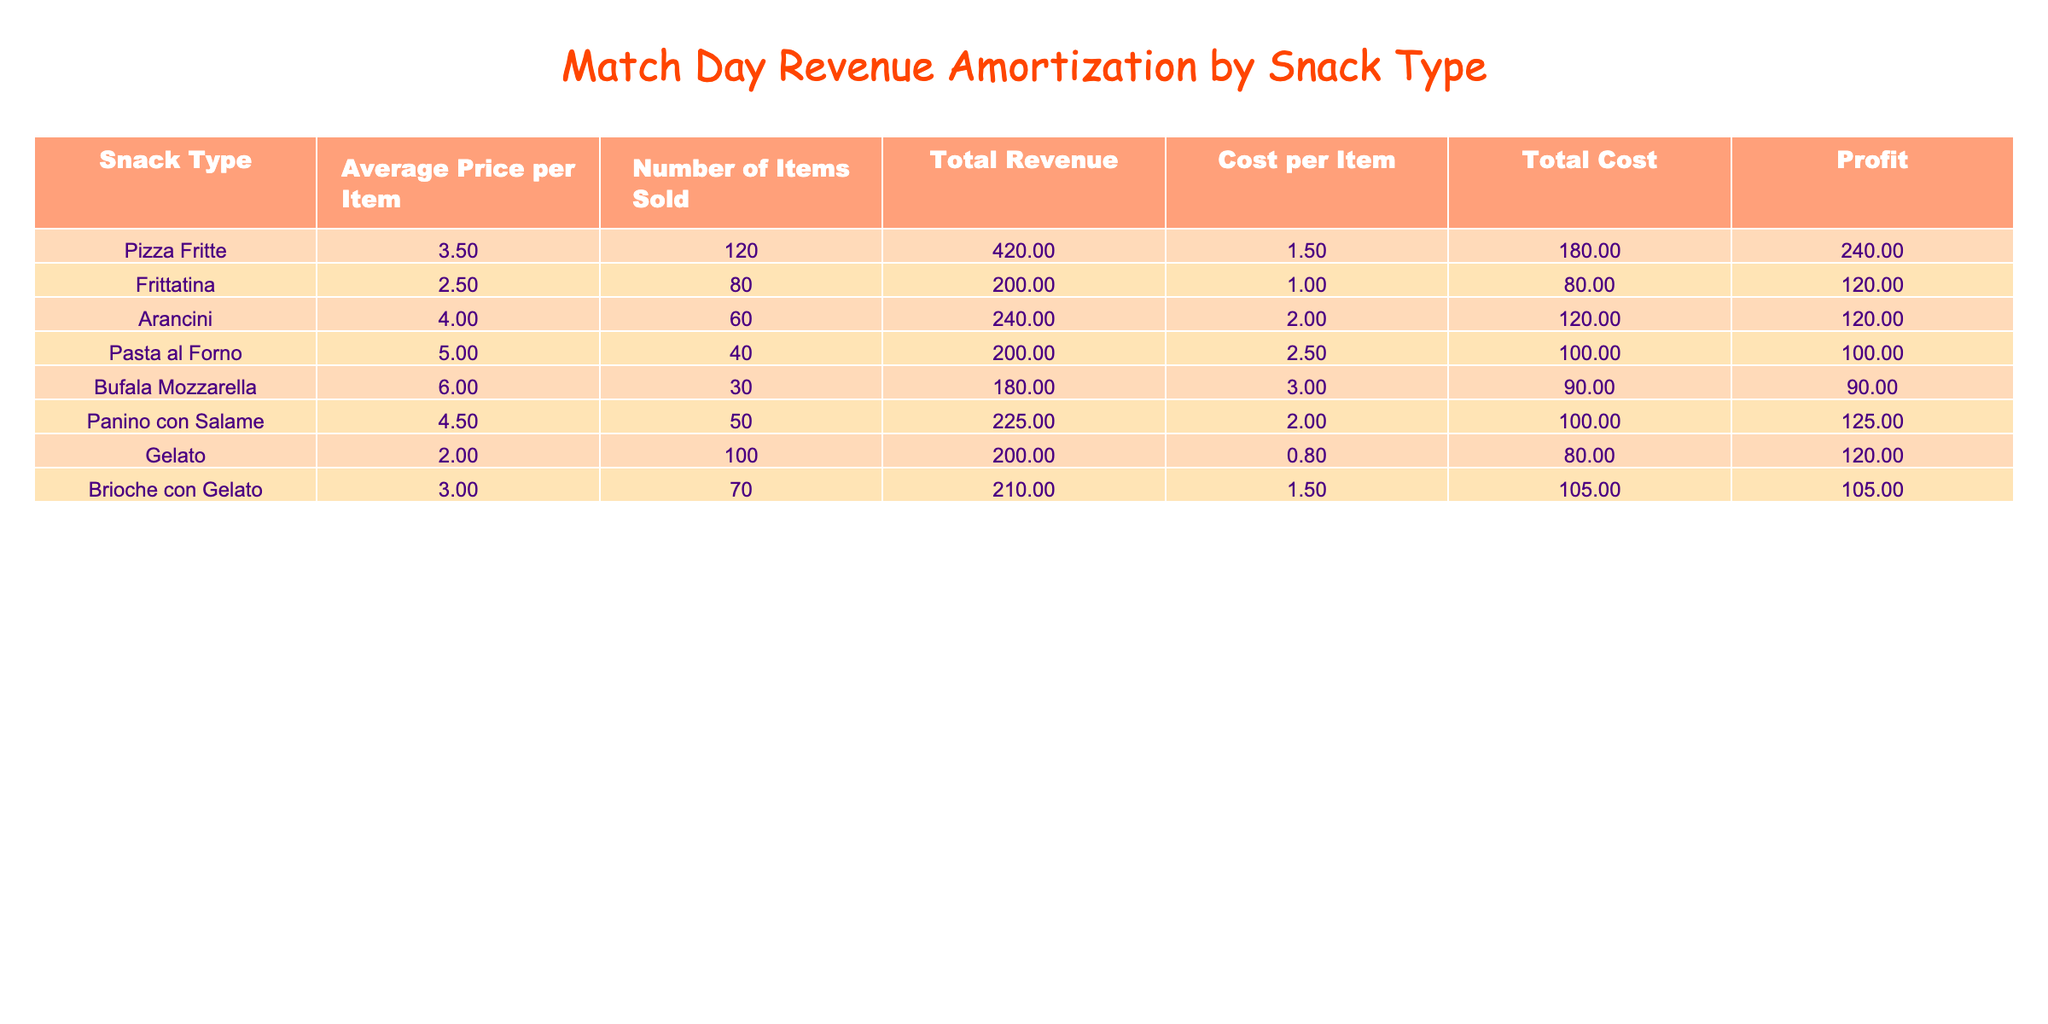What is the total revenue generated from Pizza Fritte? According to the table, the total revenue for Pizza Fritte is listed directly in the Total Revenue column. The value is 420.00.
Answer: 420.00 How many items of Arancini were sold? Looking at the Number of Items Sold column, the entry for Arancini shows that 60 items were sold.
Answer: 60 What snack type generated the highest profit? To determine the highest profit snack, look at the Profit column. Pizza Fritte has the highest value at 240.00 compared to others.
Answer: Pizza Fritte What is the average cost per item for all snacks? To find the average cost per item, sum all values in the Cost per Item column (1.50 + 1.00 + 2.00 + 2.50 + 3.00 + 2.00 + 0.80 + 1.50) which equals 14.30, and divide by the number of snack types (8). The average is approximately 1.79.
Answer: 1.79 Is the total revenue from Frittatina greater than that from Gelato? The total revenue from Frittatina is 200.00, and for Gelato, it is also 200.00. Since they are equal, the answer is no.
Answer: No How much profit is generated from Panino con Salame compared to Bufala Mozzarella? The profit from Panino con Salame is 125.00, while the profit from Bufala Mozzarella is 90.00. The difference in profit is 125.00 - 90.00 = 35.00, so Panino con Salame generates 35.00 more.
Answer: 35.00 What is the total cost of all items sold? The total costs can be found by summing the values from the Total Cost column (180.00 + 80.00 + 120.00 + 100.00 + 90.00 + 100.00 + 80.00 + 105.00). This equals 955.00.
Answer: 955.00 Which snack had the lowest average price per item? By comparing the Average Price per Item column, Frittatina has the lowest price at 2.50, while others are higher.
Answer: Frittatina How much revenue did Arancini contribute as a percentage of the total revenue? The total revenue from all snacks is 2000.00 (420.00 + 200.00 + 240.00 + 200.00 + 180.00 + 225.00 + 200.00 + 210.00). Arancini's revenue is 240.00. So, (240.00 / 2000.00) * 100 = 12%.
Answer: 12% 